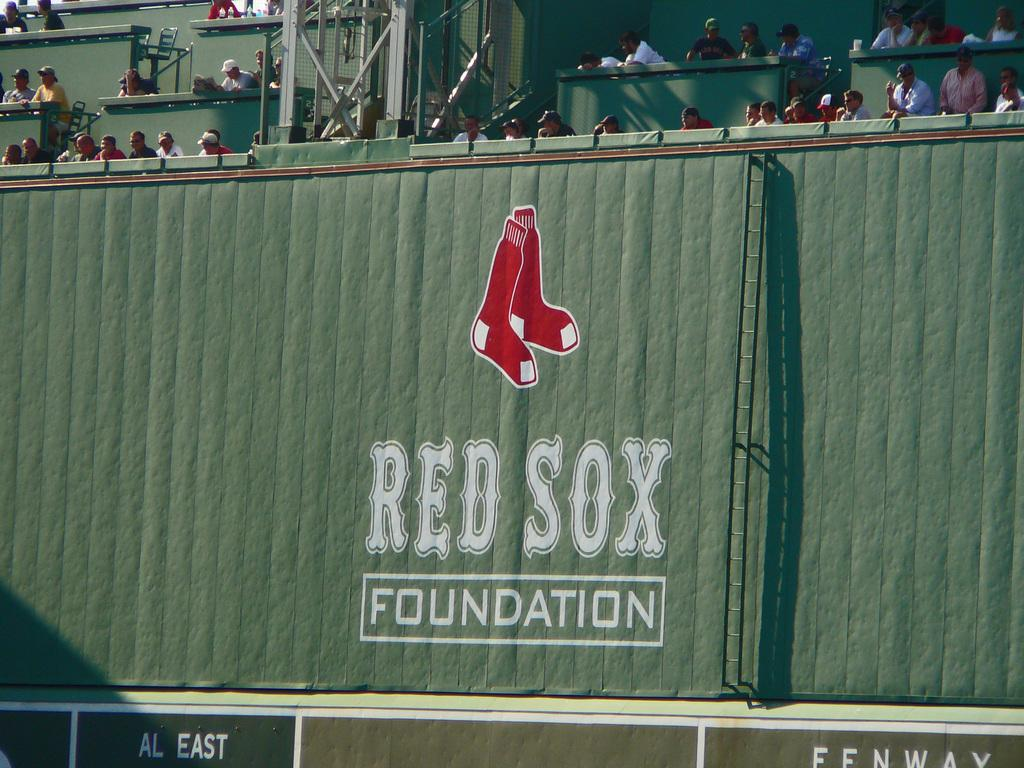<image>
Present a compact description of the photo's key features. The Red Sox Foundation logo is on a green wall 